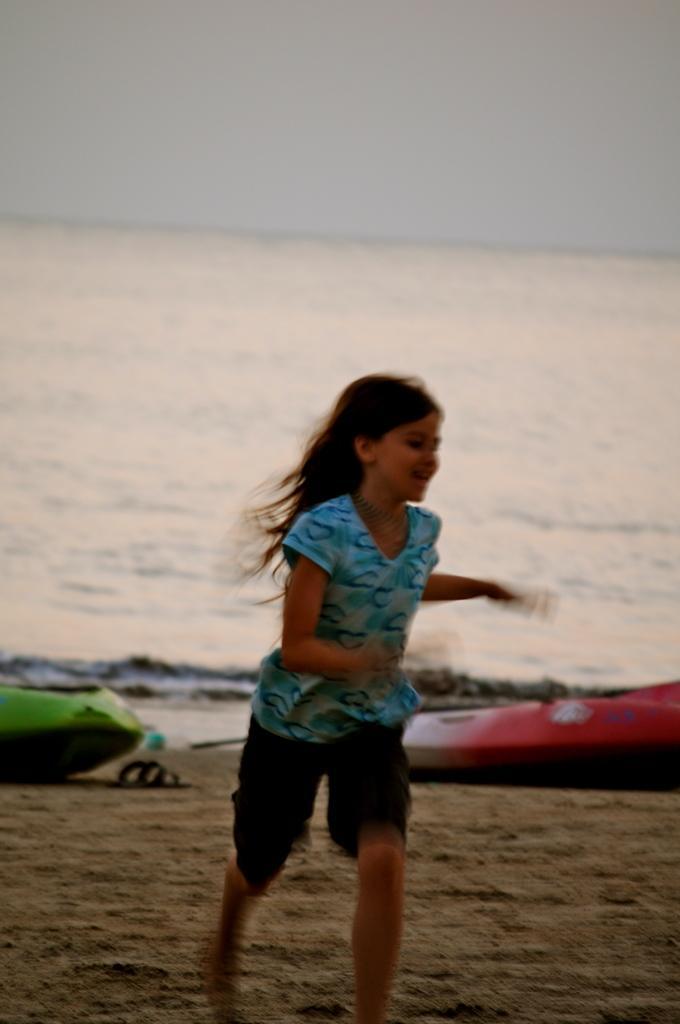How would you summarize this image in a sentence or two? In this picture we can see a girl smiling and running on sand and at the back of her we can see boats, footwear, water and some objects and in the background we can see the sky. 